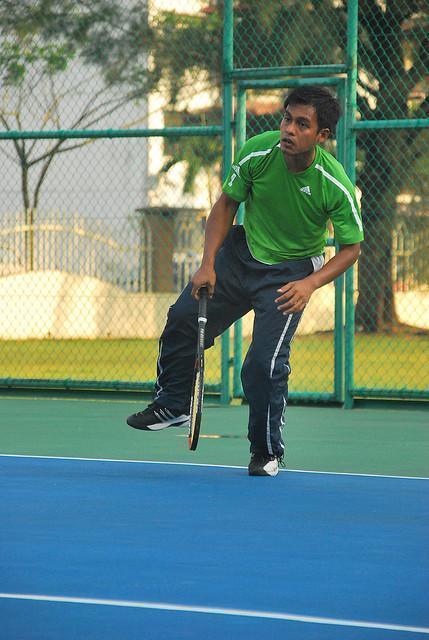How many zebras in the picture?
Give a very brief answer. 0. 